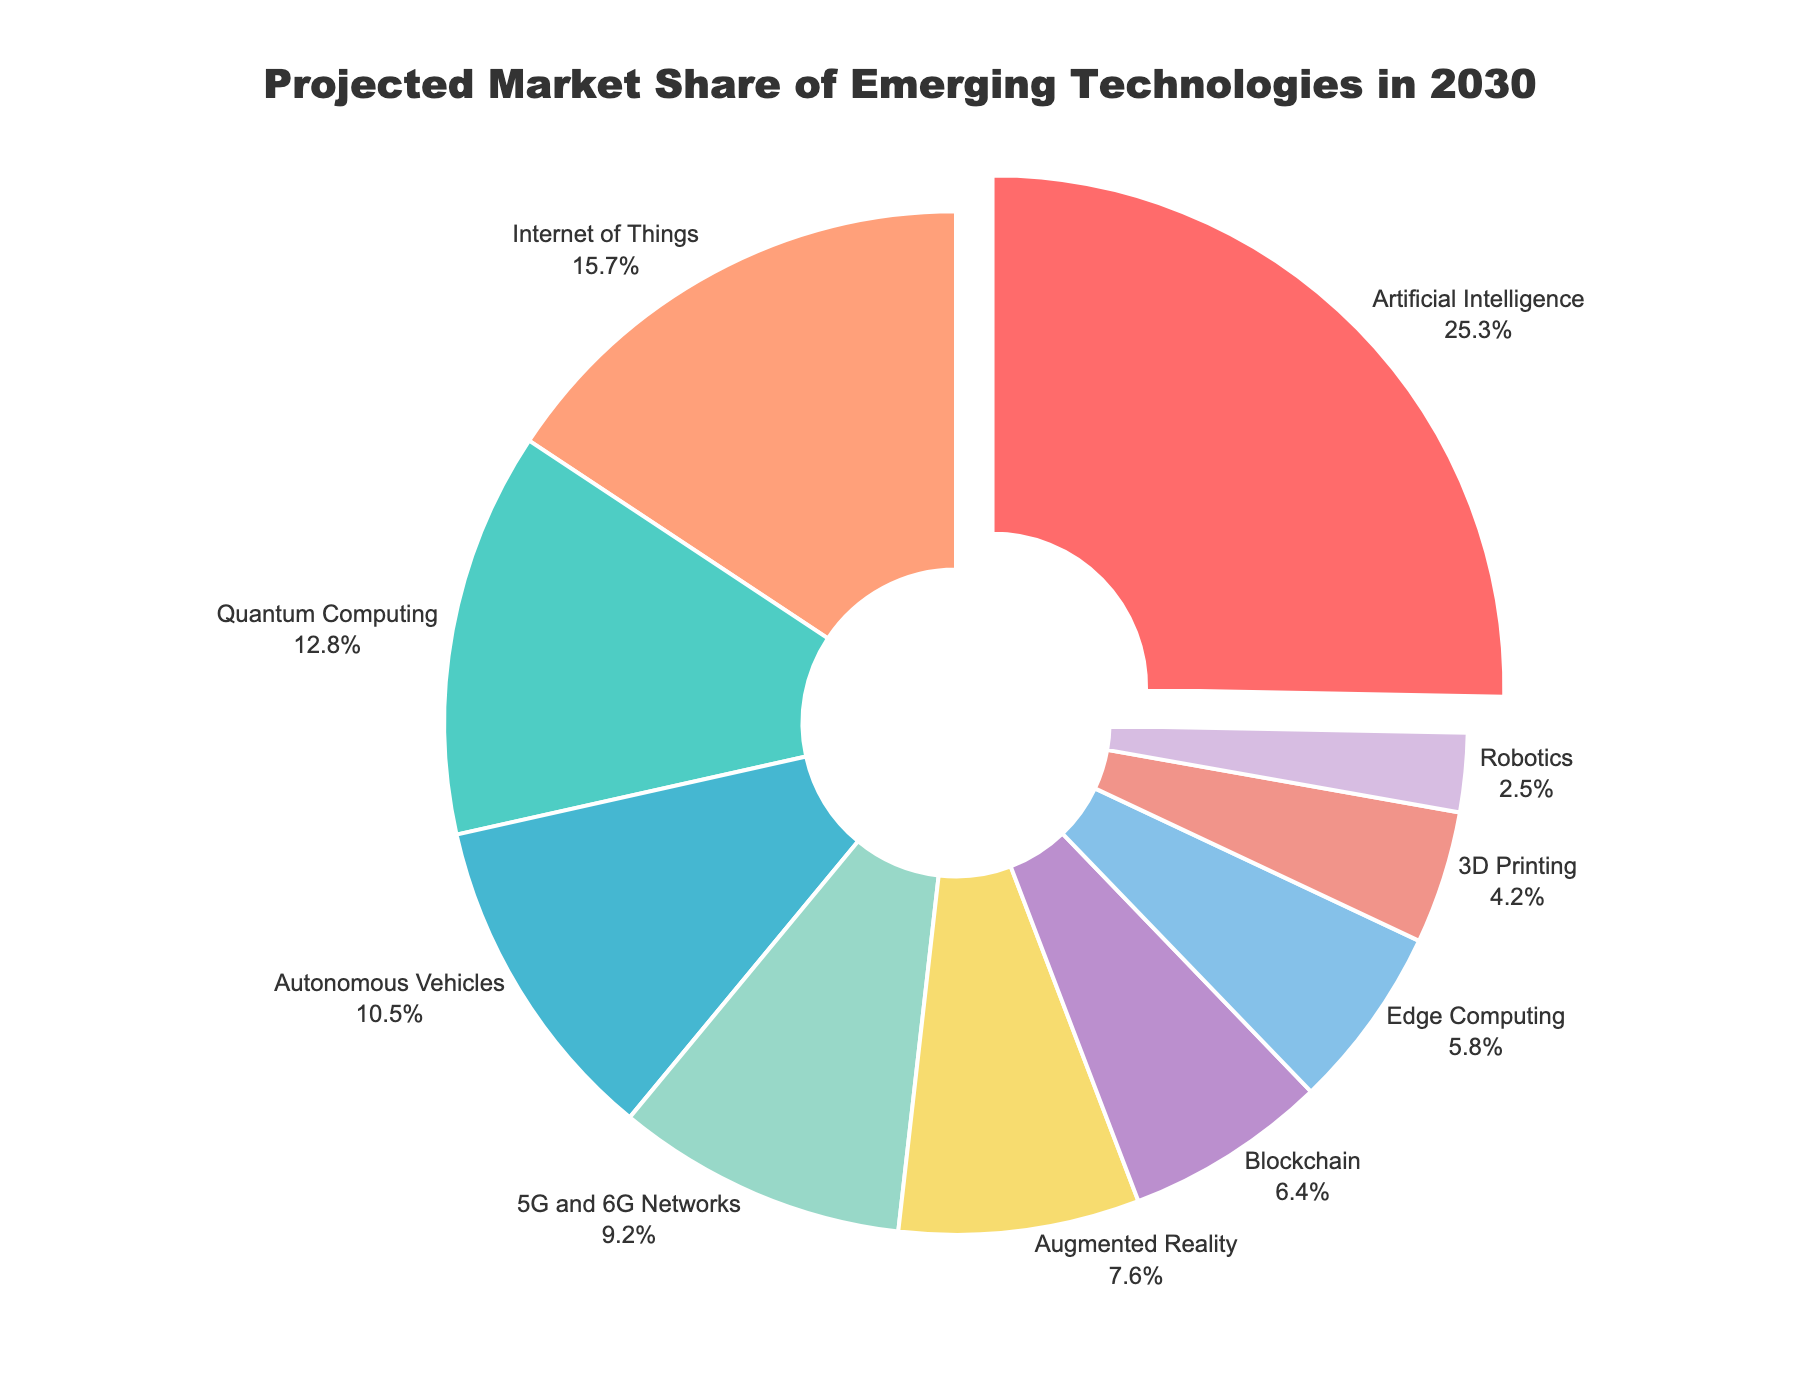What's the largest projected market share in 2030? The segment with the largest projected market share can be identified by looking at the labels with the percentages on the pie chart. The 'Artificial Intelligence' segment is the largest with 25.3%.
Answer: 25.3% Which technology holds the smallest projected market share in 2030? By examining the labels with the percentages in the pie chart, 'Robotics' has the smallest market share at 2.5%.
Answer: 2.5% How does the market share of Internet of Things compare to Quantum Computing? Looking at the pie chart labels, 'Internet of Things' is 15.7% and 'Quantum Computing' is 12.8%. Comparing these values, Internet of Things has a higher market share than Quantum Computing.
Answer: Internet of Things > Quantum Computing What is the combined market share of 3D Printing and Robotics? Adding the market shares of '3D Printing' (4.2%) and 'Robotics' (2.5%) gives us 4.2% + 2.5% = 6.7%.
Answer: 6.7% Which technologies have a projected market share below 10%? By reviewing the pie chart, '5G and 6G Networks' (9.2%), 'Augmented Reality' (7.6%), 'Blockchain' (6.4%), 'Edge Computing' (5.8%), '3D Printing' (4.2%), and 'Robotics' (2.5%) all have market shares below 10%.
Answer: 5G and 6G Networks, Augmented Reality, Blockchain, Edge Computing, 3D Printing, Robotics What percentage of the market share is accounted for by AI, IoT, and Autonomous Vehicles combined? Adding the market shares of 'Artificial Intelligence' (25.3%), 'Internet of Things' (15.7%), and 'Autonomous Vehicles' (10.5%) results in 25.3% + 15.7% + 10.5% = 51.5%.
Answer: 51.5% What is the difference in market share percentage between Augmented Reality and Edge Computing? Subtract the market share of 'Edge Computing' (5.8%) from 'Augmented Reality' (7.6%), yielding 7.6% - 5.8% = 1.8%.
Answer: 1.8% If you exclude the top three technologies, what is the total market share of the remaining technologies? The top three technologies are Artificial Intelligence (25.3%), Internet of Things (15.7%), and Quantum Computing (12.8%). Summing their market shares: 25.3% + 15.7% + 12.8% = 53.8%. The total market share of all technologies is 100%, so the remaining technologies account for 100% - 53.8% = 46.2%.
Answer: 46.2% How is the 'Artificial Intelligence' segment visually highlighted in the pie chart? The 'Artificial Intelligence' segment is visually highlighted by being pulled out slightly from the rest of the pie chart segments.
Answer: Pulled out What is the average market share of the technologies shown in the pie chart? Sum all the market share percentages and divide by the number of technologies: (25.3 + 12.8 + 10.5 + 15.7 + 9.2 + 7.6 + 6.4 + 5.8 + 4.2 + 2.5) / 10 = 100 / 10 = 10%.
Answer: 10% 